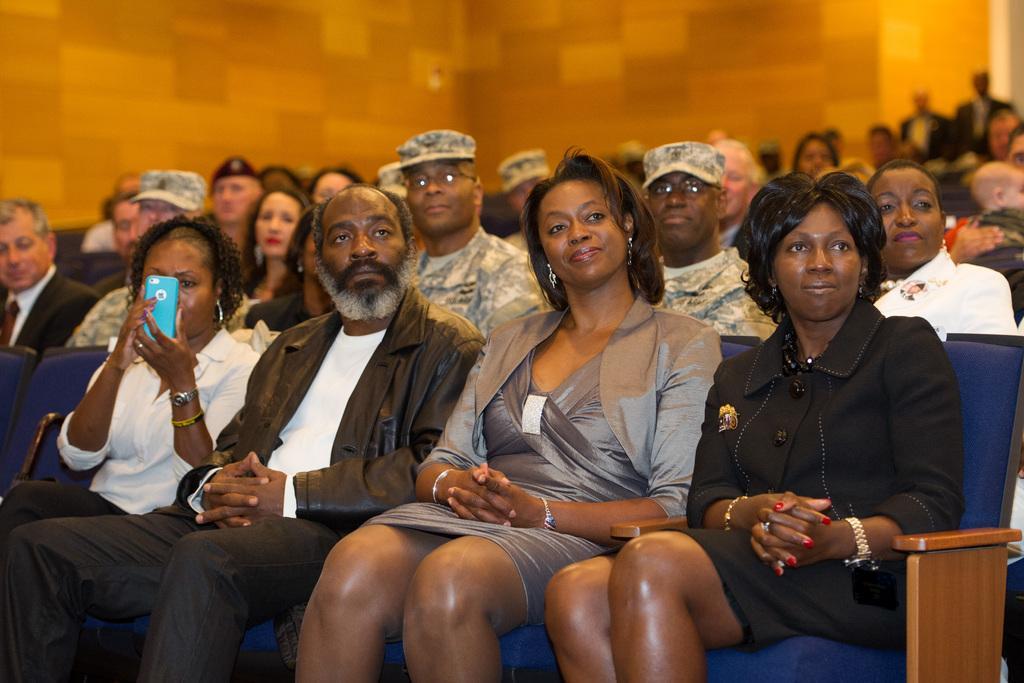Describe this image in one or two sentences. In this image, we can see persons wearing clothes and sitting on chairs. There is a wall at the top of the image. 